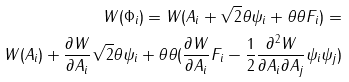<formula> <loc_0><loc_0><loc_500><loc_500>W ( \Phi _ { i } ) = W ( A _ { i } + \sqrt { 2 } \theta \psi _ { i } + \theta \theta F _ { i } ) = \\ W ( A _ { i } ) + \frac { \partial W } { \partial A _ { i } } \sqrt { 2 } \theta \psi _ { i } + \theta \theta ( \frac { \partial W } { \partial A _ { i } } F _ { i } - \frac { 1 } { 2 } \frac { \partial ^ { 2 } W } { \partial A _ { i } \partial A _ { j } } \psi _ { i } \psi _ { j } )</formula> 